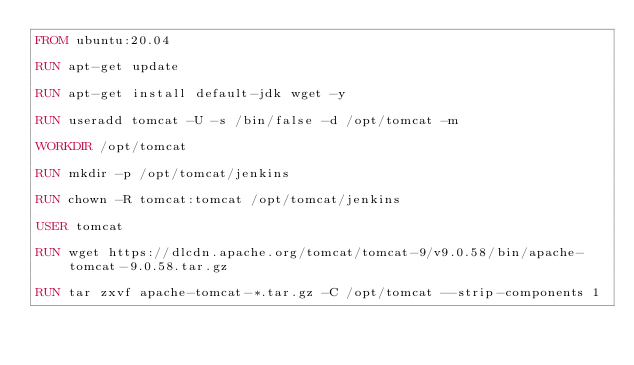Convert code to text. <code><loc_0><loc_0><loc_500><loc_500><_Dockerfile_>FROM ubuntu:20.04

RUN apt-get update

RUN apt-get install default-jdk wget -y

RUN useradd tomcat -U -s /bin/false -d /opt/tomcat -m

WORKDIR /opt/tomcat

RUN mkdir -p /opt/tomcat/jenkins

RUN chown -R tomcat:tomcat /opt/tomcat/jenkins

USER tomcat

RUN wget https://dlcdn.apache.org/tomcat/tomcat-9/v9.0.58/bin/apache-tomcat-9.0.58.tar.gz

RUN tar zxvf apache-tomcat-*.tar.gz -C /opt/tomcat --strip-components 1
</code> 